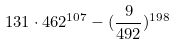<formula> <loc_0><loc_0><loc_500><loc_500>1 3 1 \cdot 4 6 2 ^ { 1 0 7 } - ( \frac { 9 } { 4 9 2 } ) ^ { 1 9 8 }</formula> 